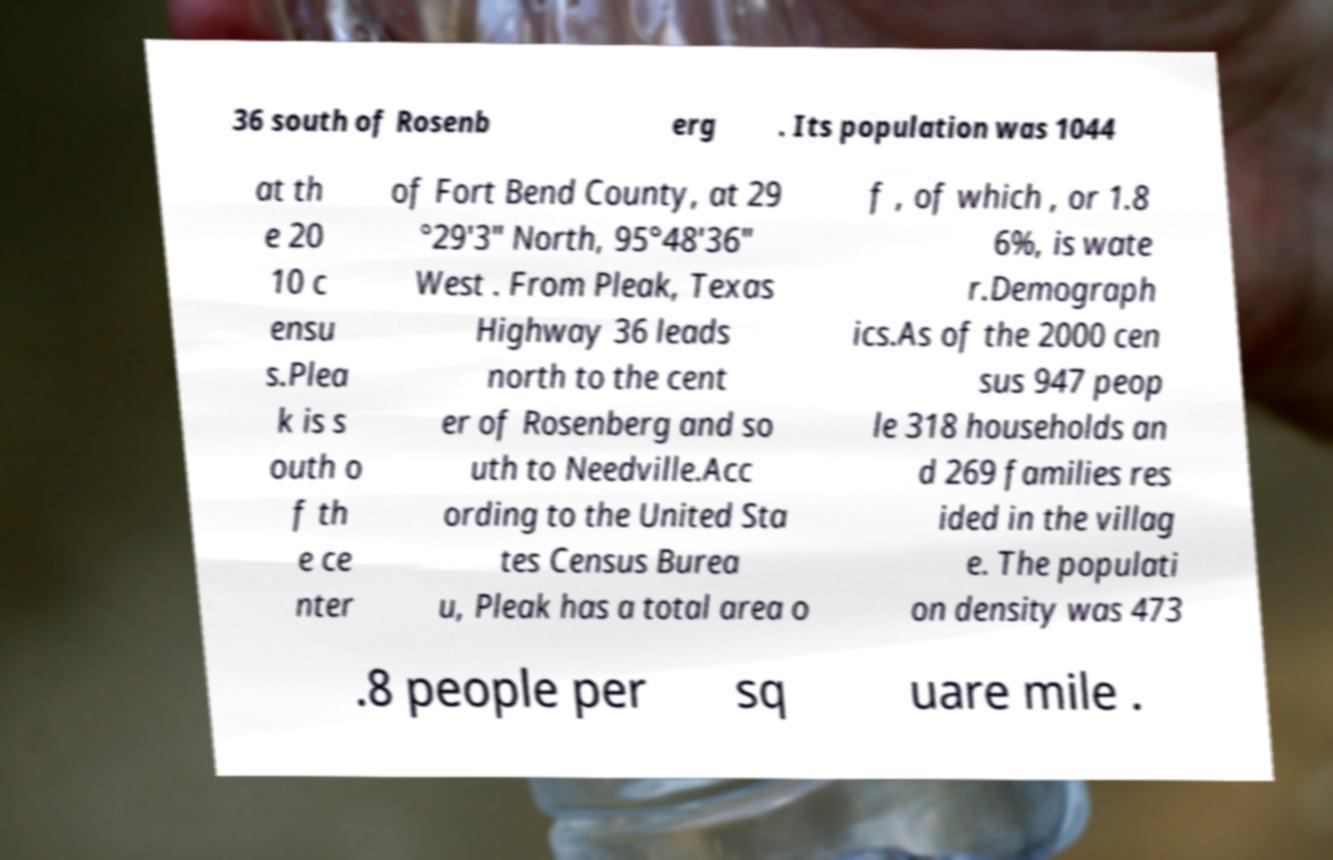Could you assist in decoding the text presented in this image and type it out clearly? 36 south of Rosenb erg . Its population was 1044 at th e 20 10 c ensu s.Plea k is s outh o f th e ce nter of Fort Bend County, at 29 °29'3" North, 95°48'36" West . From Pleak, Texas Highway 36 leads north to the cent er of Rosenberg and so uth to Needville.Acc ording to the United Sta tes Census Burea u, Pleak has a total area o f , of which , or 1.8 6%, is wate r.Demograph ics.As of the 2000 cen sus 947 peop le 318 households an d 269 families res ided in the villag e. The populati on density was 473 .8 people per sq uare mile . 